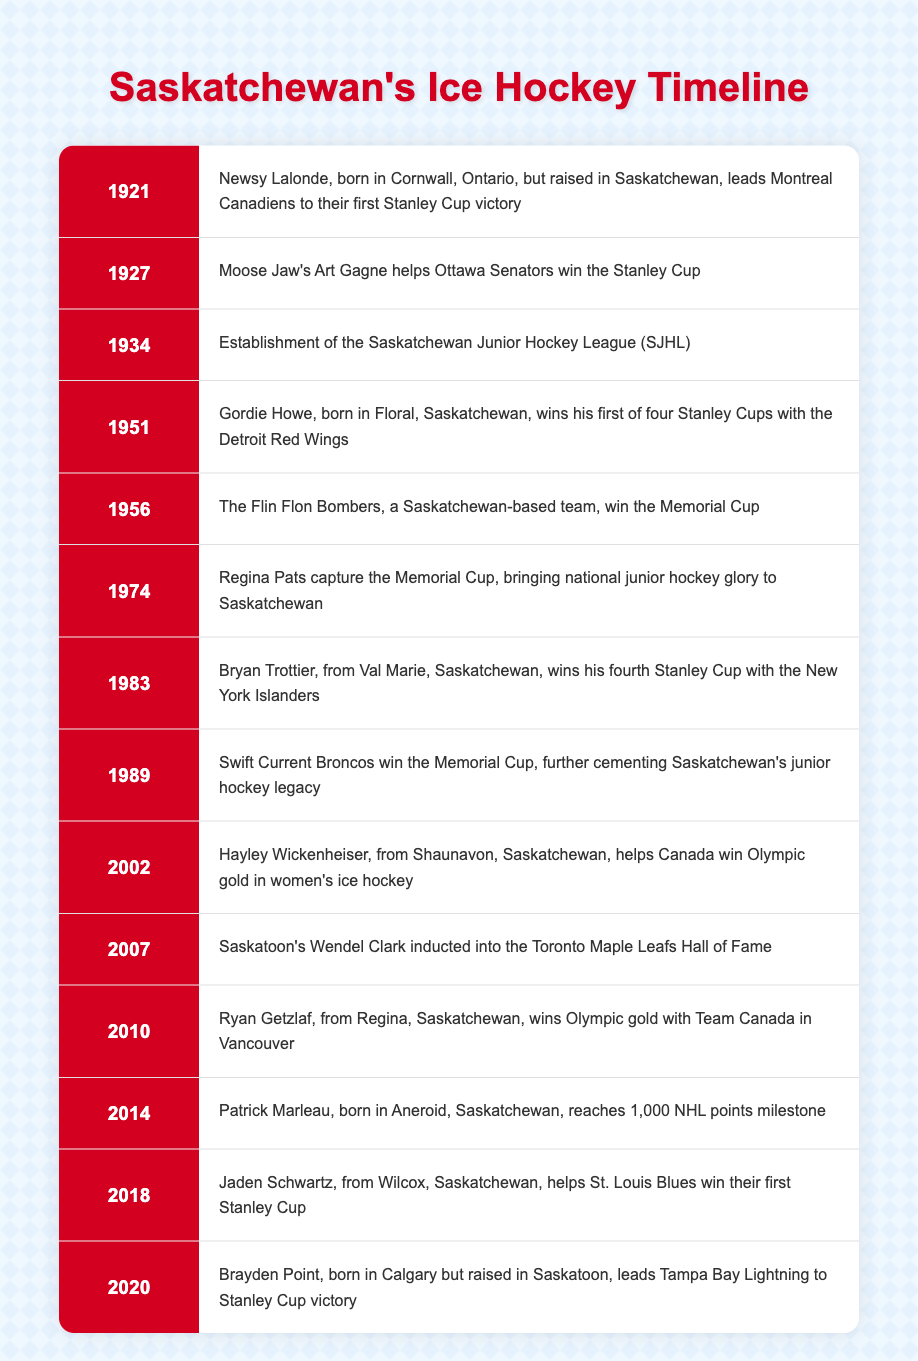What year did Newsy Lalonde lead the Montreal Canadiens to their first Stanley Cup victory? The table indicates that this event occurred in 1921 next to Newsy Lalonde's name.
Answer: 1921 Who helped the Ottawa Senators win the Stanley Cup in 1927? According to the table, the event in 1927 states that Moose Jaw's Art Gagne was the one who helped the Ottawa Senators win the Stanley Cup.
Answer: Art Gagne Did Hayley Wickenheiser contribute to any Olympic gold medals in women's ice hockey? The table confirms that in 2002, Hayley Wickenheiser helped Canada win Olympic gold, thus indicating that she did contribute to Olympic success.
Answer: Yes How many times did Gordie Howe win the Stanley Cup with the Detroit Red Wings? The timeline shows that he won his first Stanley Cup in 1951, and although it mentions he has four in total, further context would be needed to specify. Based on context, it is known that he won four.
Answer: Four In what year did Regina Pats capture the Memorial Cup? The event description for 1974 in the table specifically mentions that Regina Pats captured the Memorial Cup in that year.
Answer: 1974 What is the difference between the first Stanley Cup win mentioned for Gordie Howe and his milestone year in 2014? Gordie Howe first won the Stanley Cup in 1951, and the milestone event in 2014 relates to Patrick Marleau; the situation asks for the difference in years which is calculated as 2014 - 1951 = 63 years.
Answer: 63 years Who from Saskatchewan helped the St. Louis Blues win their first Stanley Cup? The table specifies that Jaden Schwartz, from Wilcox, Saskatchewan, was instrumental in this victory in 2018.
Answer: Jaden Schwartz How many more Memorial Cup victories are listed after the year 1974? In the table, after 1974, there are two more Memorial Cup victories mentioned in 1989 and 2002 (Flin Flon Bombers in 1956 and Swift Current Broncos in 1989, totaling three including Regina Pats) resulting in a total of three.
Answer: Two more victories Did Brayden Point lead the Tampa Bay Lightning to a Stanley Cup victory while being raised in Saskatoon? The mentioned event for 2020 indicates that Brayden Point, though born in Calgary, was raised in Saskatoon and led his team to victory, confirming this fact.
Answer: Yes 